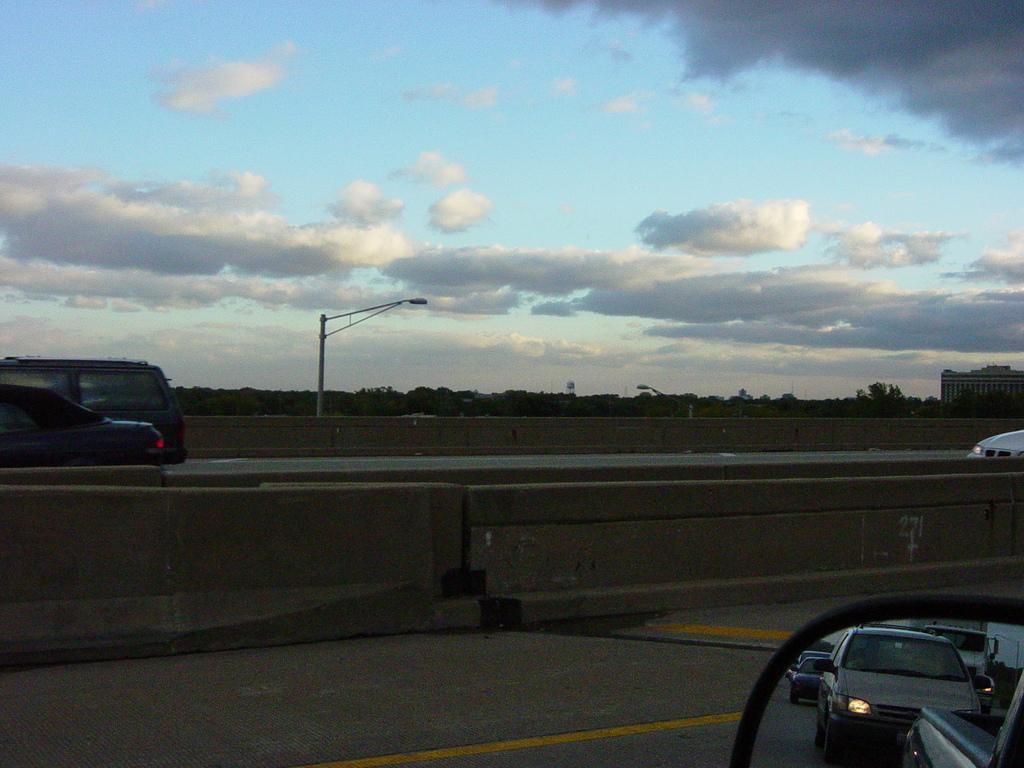Please provide a concise description of this image. In this image on the road many vehicles are moving. In the background there are trees, street light, building. The sky is cloudy. 